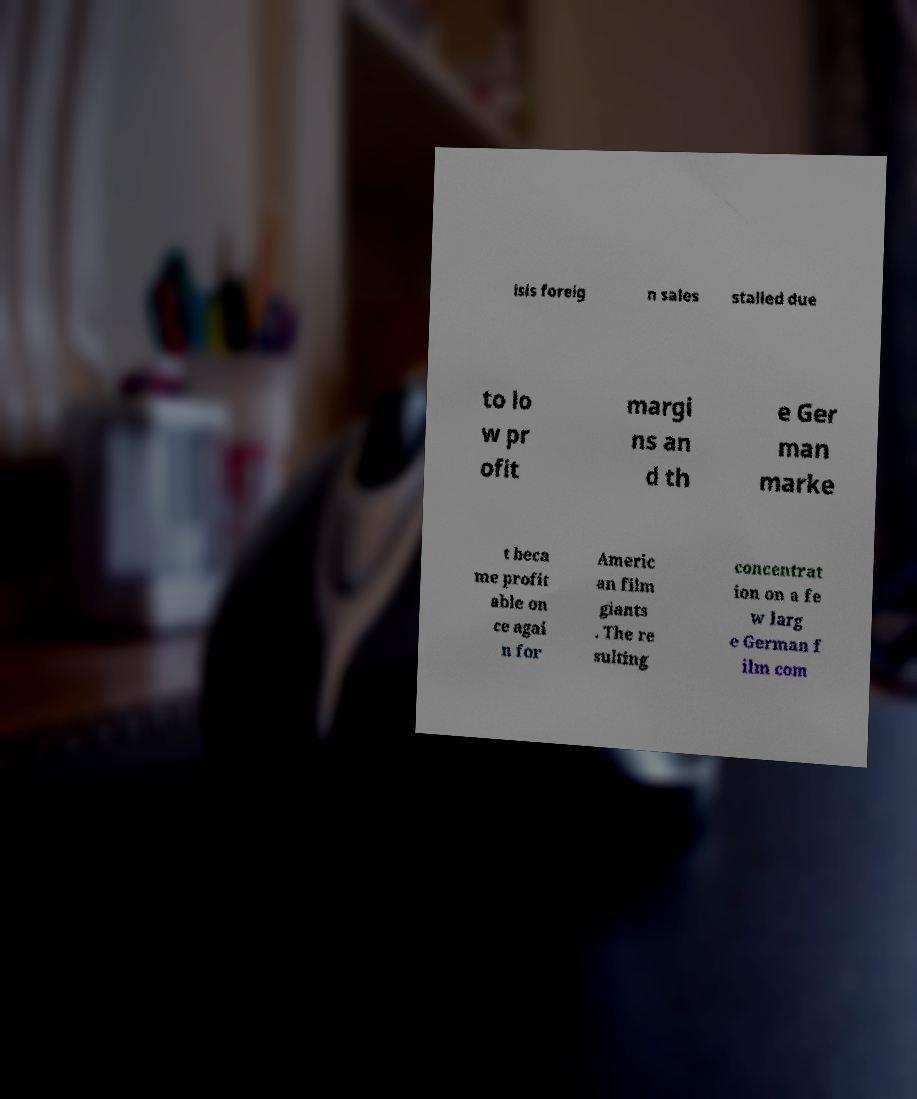I need the written content from this picture converted into text. Can you do that? isis foreig n sales stalled due to lo w pr ofit margi ns an d th e Ger man marke t beca me profit able on ce agai n for Americ an film giants . The re sulting concentrat ion on a fe w larg e German f ilm com 